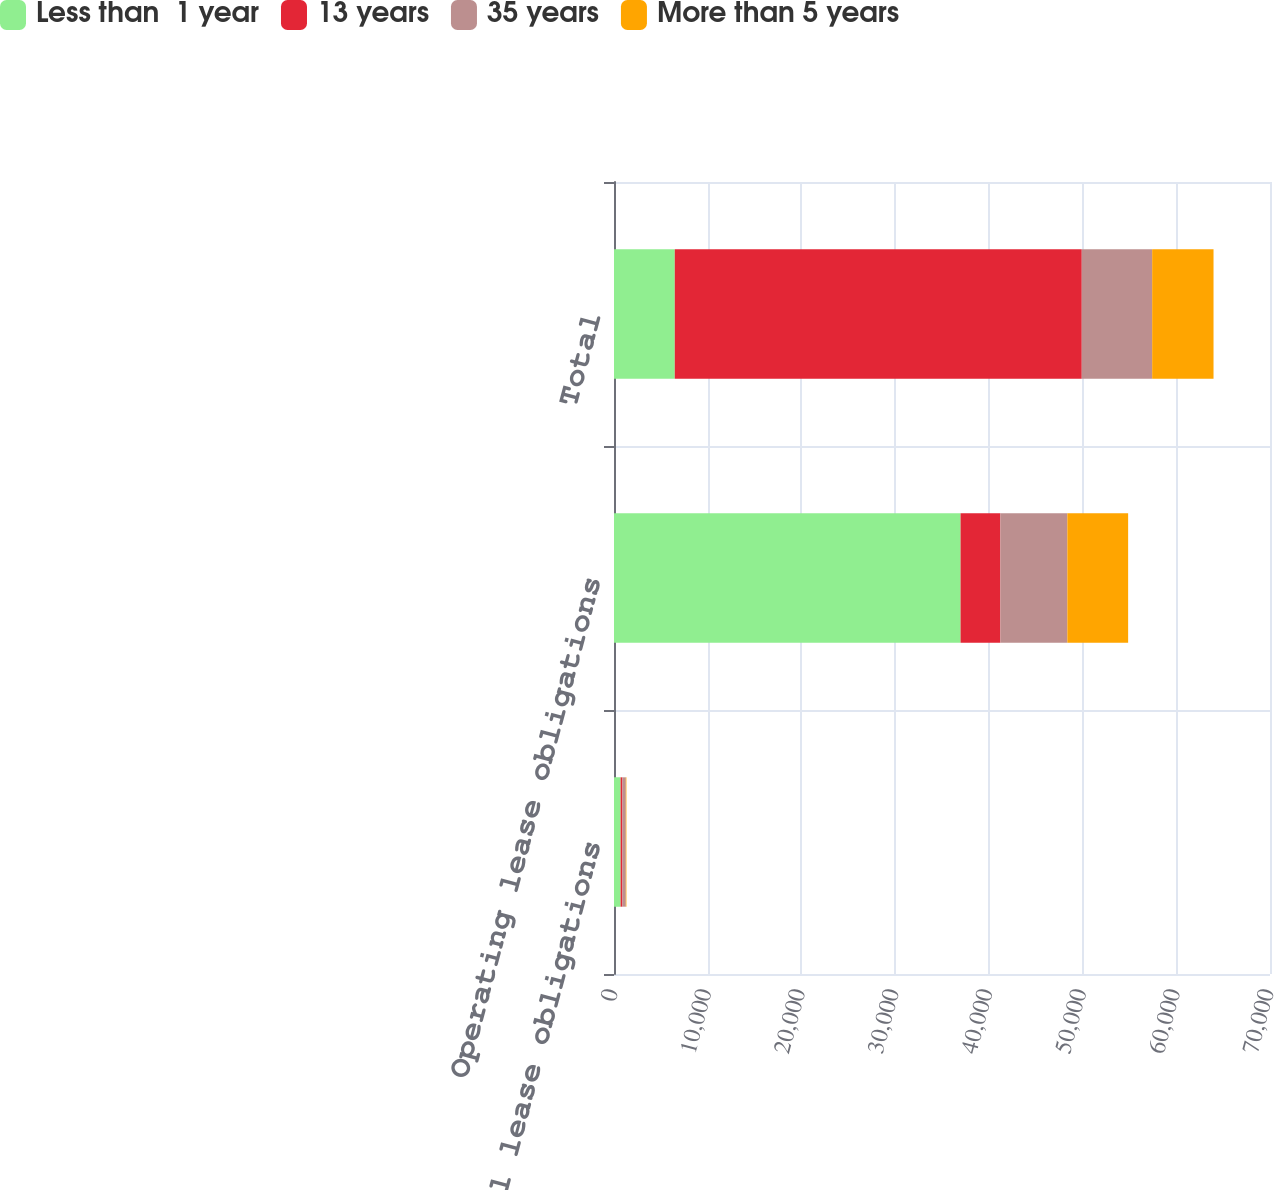Convert chart. <chart><loc_0><loc_0><loc_500><loc_500><stacked_bar_chart><ecel><fcel>Capital lease obligations<fcel>Operating lease obligations<fcel>Total<nl><fcel>Less than  1 year<fcel>705<fcel>36982<fcel>6486<nl><fcel>13 years<fcel>190<fcel>4248<fcel>43428<nl><fcel>35 years<fcel>365<fcel>7146<fcel>7511<nl><fcel>More than 5 years<fcel>63<fcel>6486<fcel>6549<nl></chart> 